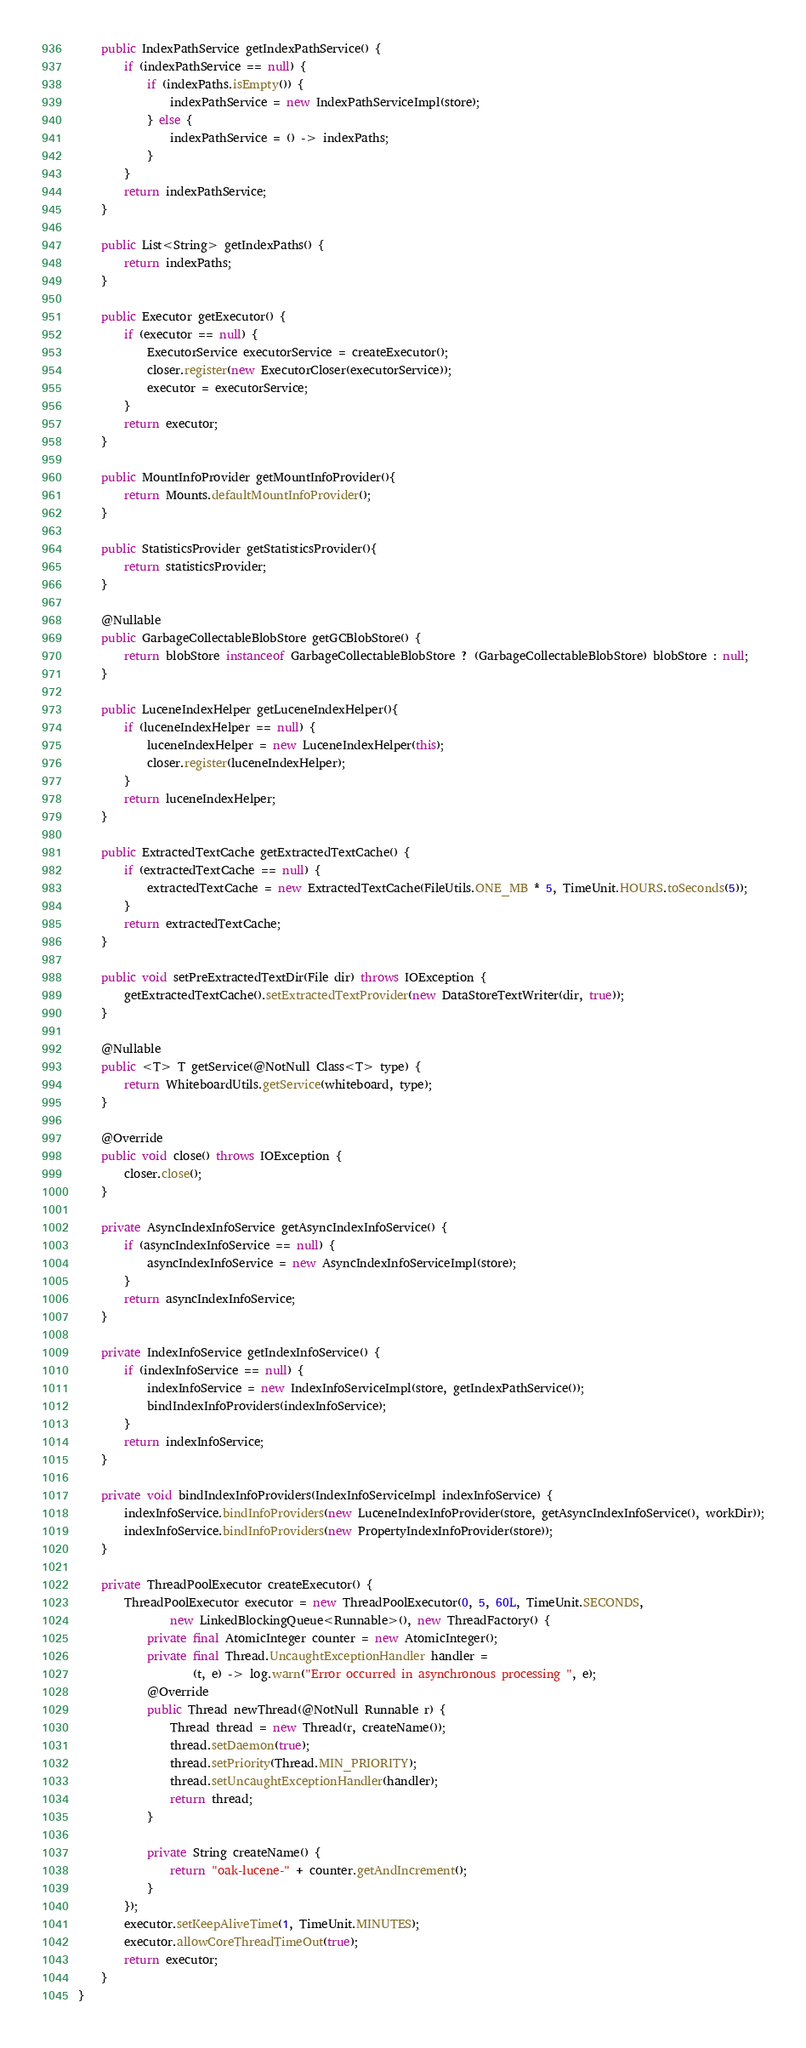Convert code to text. <code><loc_0><loc_0><loc_500><loc_500><_Java_>    public IndexPathService getIndexPathService() {
        if (indexPathService == null) {
            if (indexPaths.isEmpty()) {
                indexPathService = new IndexPathServiceImpl(store);
            } else {
                indexPathService = () -> indexPaths;
            }
        }
        return indexPathService;
    }

    public List<String> getIndexPaths() {
        return indexPaths;
    }

    public Executor getExecutor() {
        if (executor == null) {
            ExecutorService executorService = createExecutor();
            closer.register(new ExecutorCloser(executorService));
            executor = executorService;
        }
        return executor;
    }

    public MountInfoProvider getMountInfoProvider(){
        return Mounts.defaultMountInfoProvider();
    }

    public StatisticsProvider getStatisticsProvider(){
        return statisticsProvider;
    }

    @Nullable
    public GarbageCollectableBlobStore getGCBlobStore() {
        return blobStore instanceof GarbageCollectableBlobStore ? (GarbageCollectableBlobStore) blobStore : null;
    }

    public LuceneIndexHelper getLuceneIndexHelper(){
        if (luceneIndexHelper == null) {
            luceneIndexHelper = new LuceneIndexHelper(this);
            closer.register(luceneIndexHelper);
        }
        return luceneIndexHelper;
    }

    public ExtractedTextCache getExtractedTextCache() {
        if (extractedTextCache == null) {
            extractedTextCache = new ExtractedTextCache(FileUtils.ONE_MB * 5, TimeUnit.HOURS.toSeconds(5));
        }
        return extractedTextCache;
    }

    public void setPreExtractedTextDir(File dir) throws IOException {
        getExtractedTextCache().setExtractedTextProvider(new DataStoreTextWriter(dir, true));
    }

    @Nullable
    public <T> T getService(@NotNull Class<T> type) {
        return WhiteboardUtils.getService(whiteboard, type);
    }

    @Override
    public void close() throws IOException {
        closer.close();
    }

    private AsyncIndexInfoService getAsyncIndexInfoService() {
        if (asyncIndexInfoService == null) {
            asyncIndexInfoService = new AsyncIndexInfoServiceImpl(store);
        }
        return asyncIndexInfoService;
    }

    private IndexInfoService getIndexInfoService() {
        if (indexInfoService == null) {
            indexInfoService = new IndexInfoServiceImpl(store, getIndexPathService());
            bindIndexInfoProviders(indexInfoService);
        }
        return indexInfoService;
    }

    private void bindIndexInfoProviders(IndexInfoServiceImpl indexInfoService) {
        indexInfoService.bindInfoProviders(new LuceneIndexInfoProvider(store, getAsyncIndexInfoService(), workDir));
        indexInfoService.bindInfoProviders(new PropertyIndexInfoProvider(store));
    }

    private ThreadPoolExecutor createExecutor() {
        ThreadPoolExecutor executor = new ThreadPoolExecutor(0, 5, 60L, TimeUnit.SECONDS,
                new LinkedBlockingQueue<Runnable>(), new ThreadFactory() {
            private final AtomicInteger counter = new AtomicInteger();
            private final Thread.UncaughtExceptionHandler handler =
                    (t, e) -> log.warn("Error occurred in asynchronous processing ", e);
            @Override
            public Thread newThread(@NotNull Runnable r) {
                Thread thread = new Thread(r, createName());
                thread.setDaemon(true);
                thread.setPriority(Thread.MIN_PRIORITY);
                thread.setUncaughtExceptionHandler(handler);
                return thread;
            }

            private String createName() {
                return "oak-lucene-" + counter.getAndIncrement();
            }
        });
        executor.setKeepAliveTime(1, TimeUnit.MINUTES);
        executor.allowCoreThreadTimeOut(true);
        return executor;
    }
}
</code> 